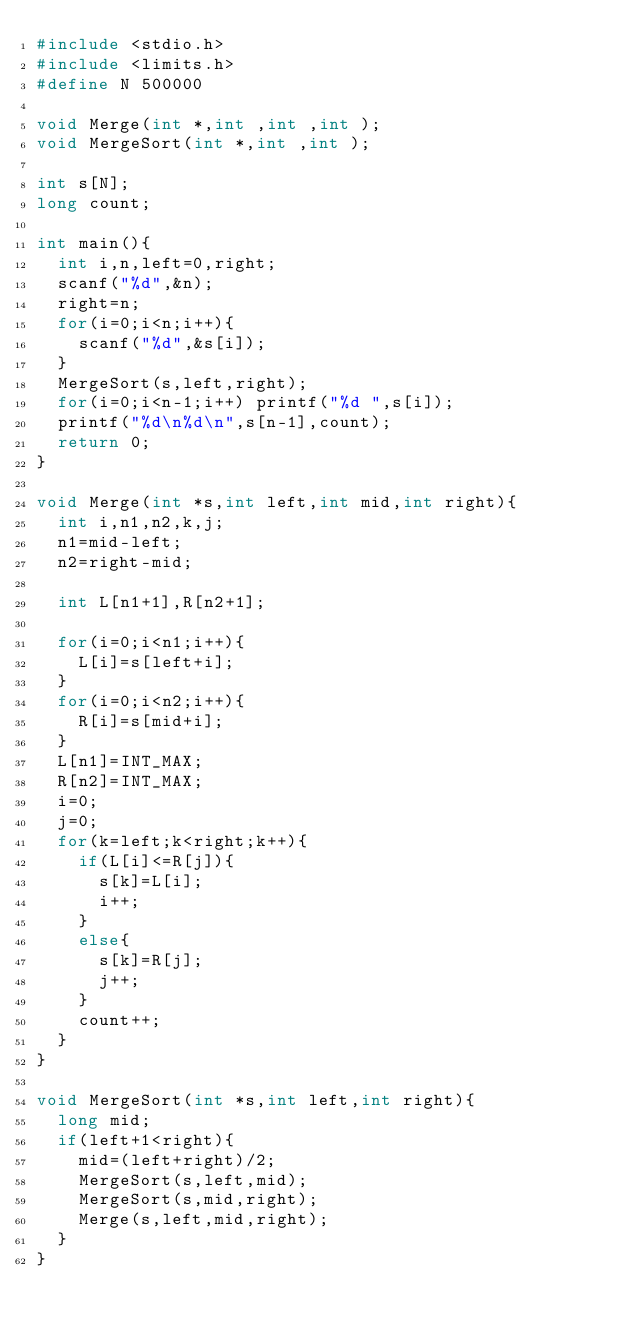Convert code to text. <code><loc_0><loc_0><loc_500><loc_500><_C_>#include <stdio.h>
#include <limits.h>
#define N 500000

void Merge(int *,int ,int ,int );
void MergeSort(int *,int ,int );

int s[N];
long count;

int main(){
  int i,n,left=0,right;
  scanf("%d",&n);
  right=n;
  for(i=0;i<n;i++){
    scanf("%d",&s[i]);
  }
  MergeSort(s,left,right);
  for(i=0;i<n-1;i++) printf("%d ",s[i]);
  printf("%d\n%d\n",s[n-1],count);
  return 0;
}

void Merge(int *s,int left,int mid,int right){
  int i,n1,n2,k,j;
  n1=mid-left;
  n2=right-mid;
  
  int L[n1+1],R[n2+1];
  
  for(i=0;i<n1;i++){
    L[i]=s[left+i];
  }
  for(i=0;i<n2;i++){
    R[i]=s[mid+i];
  }
  L[n1]=INT_MAX;
  R[n2]=INT_MAX;
  i=0;
  j=0;
  for(k=left;k<right;k++){
    if(L[i]<=R[j]){
      s[k]=L[i];
      i++;
    }
    else{
      s[k]=R[j];
      j++;
    }
    count++;
  }
}

void MergeSort(int *s,int left,int right){
  long mid;
  if(left+1<right){
    mid=(left+right)/2;
    MergeSort(s,left,mid);
    MergeSort(s,mid,right);
    Merge(s,left,mid,right);
  }
}</code> 